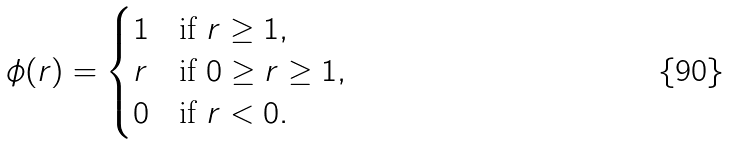Convert formula to latex. <formula><loc_0><loc_0><loc_500><loc_500>\phi ( r ) = \begin{cases} 1 & \text   {if $r\geq 1$} , \\ r & \text   {if $0\geq r \geq 1$} , \\ 0 & \text   {if $r<0$} . \end{cases}</formula> 